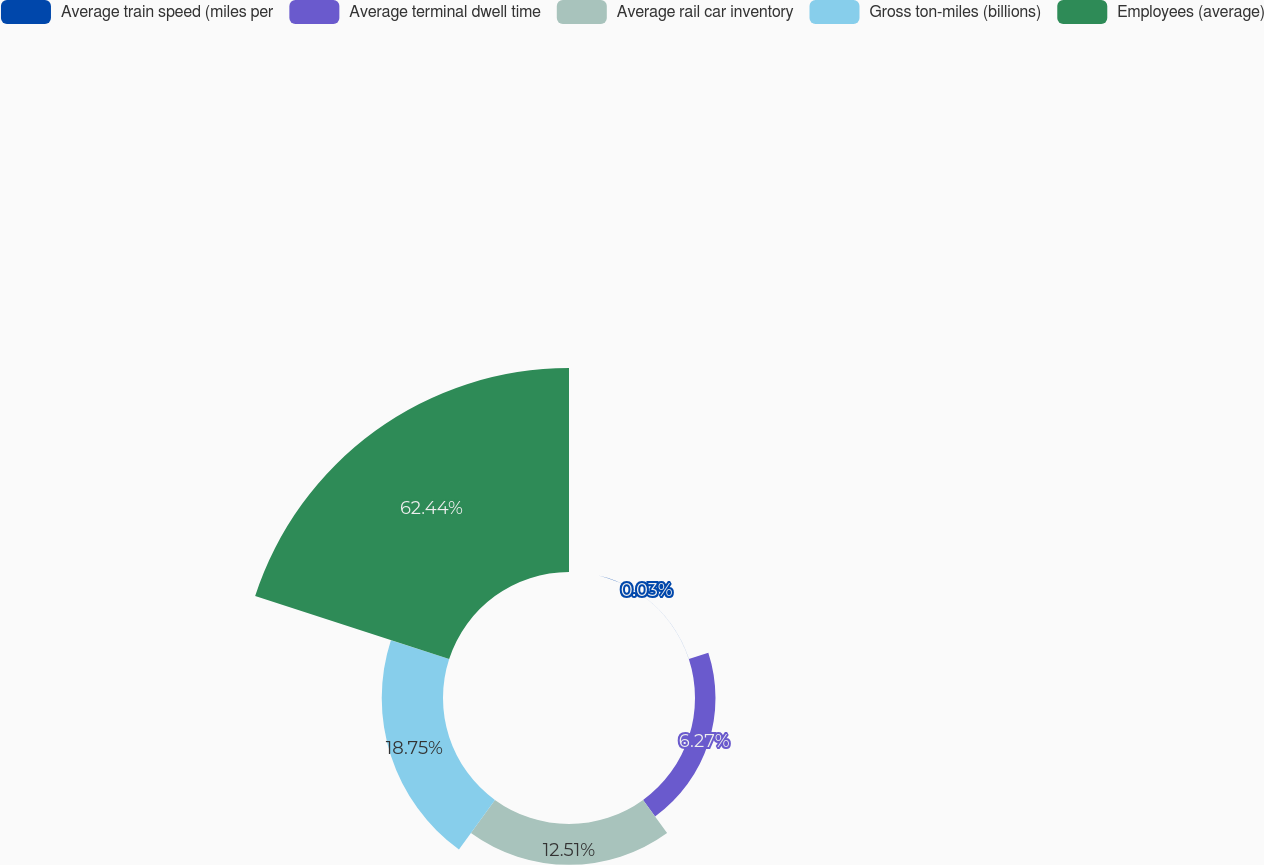<chart> <loc_0><loc_0><loc_500><loc_500><pie_chart><fcel>Average train speed (miles per<fcel>Average terminal dwell time<fcel>Average rail car inventory<fcel>Gross ton-miles (billions)<fcel>Employees (average)<nl><fcel>0.03%<fcel>6.27%<fcel>12.51%<fcel>18.75%<fcel>62.44%<nl></chart> 